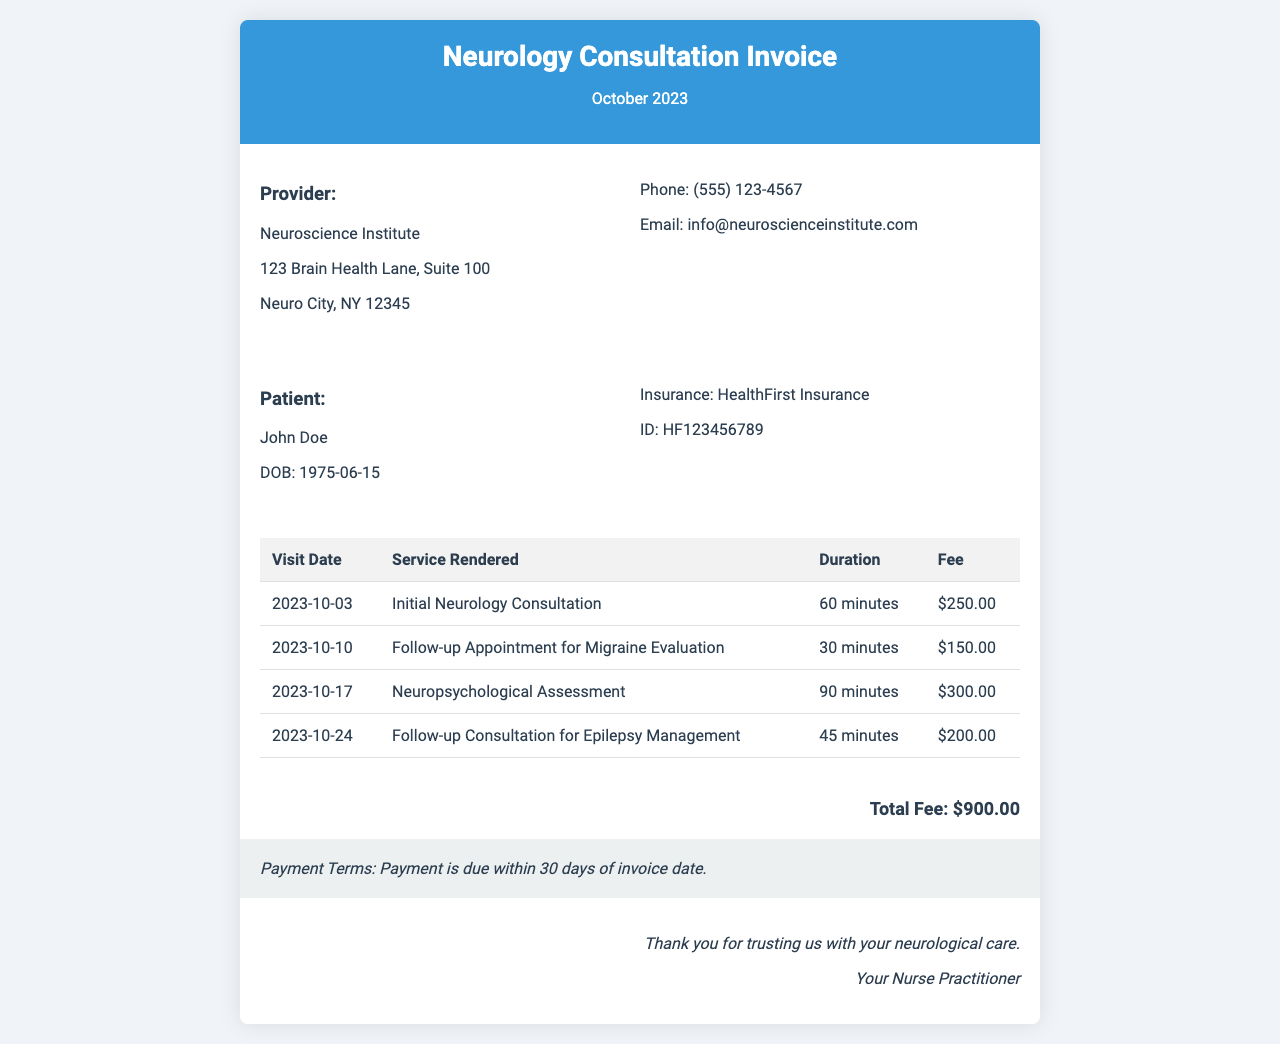What is the name of the patient? The document specifies the patient's name as John Doe.
Answer: John Doe What is the date of the initial consultation? The invoice indicates that the initial neurology consultation took place on October 3, 2023.
Answer: 2023-10-03 How much was charged for the neuropsychological assessment? The fee for the neuropsychological assessment listed in the invoice is $300.00.
Answer: $300.00 What is the total fee for all consultations? The total fee is presented at the bottom of the invoice, totaling $900.00.
Answer: $900.00 What service was rendered on October 10? The service rendered on October 10, 2023, was a follow-up appointment for migraine evaluation.
Answer: Follow-up Appointment for Migraine Evaluation How long was the initial neurology consultation? The duration of the initial neurology consultation is noted as 60 minutes.
Answer: 60 minutes When is the payment due? The payment terms state that payment is due within 30 days of the invoice date.
Answer: Within 30 days What is the provider's email address? The email address for the provider, Neuroscience Institute, is provided in the document as info@neuroscienceinstitute.com.
Answer: info@neuroscienceinstitute.com What is the total number of visits listed in the invoice? The invoice lists a total of four visits.
Answer: Four visits 